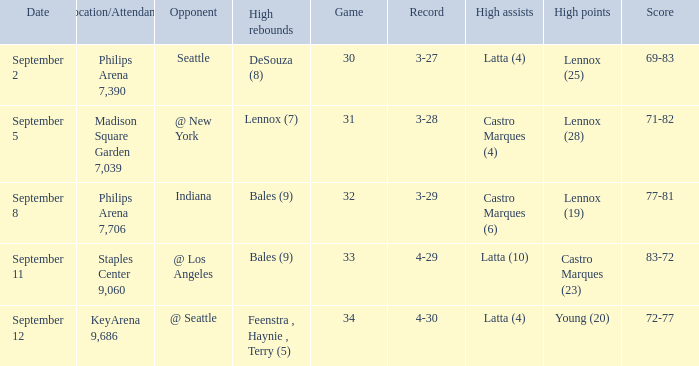When did indiana play? September 8. 